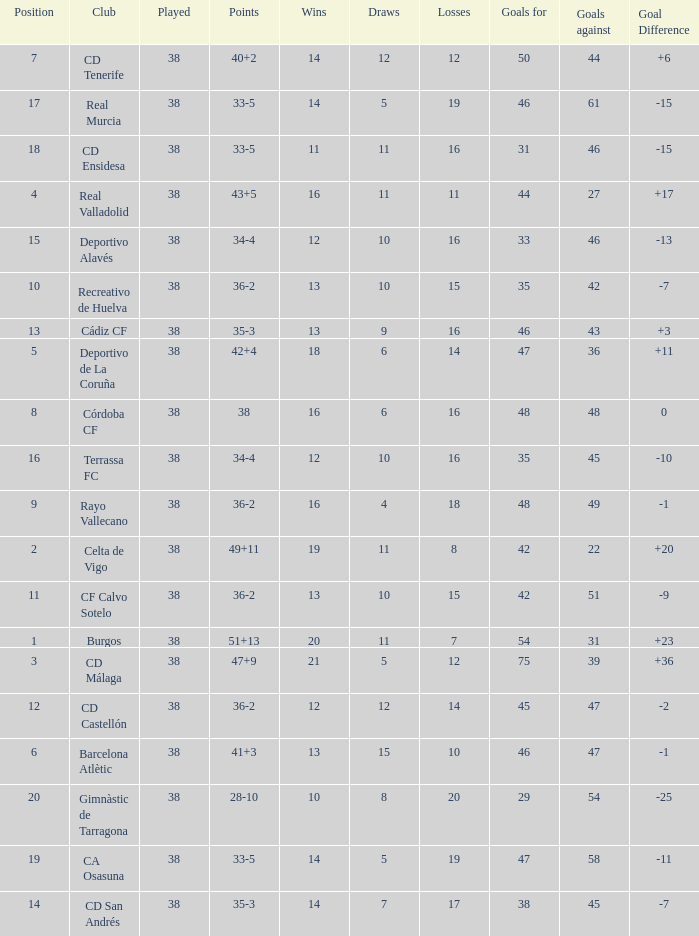Which is the lowest played with 28-10 points and goals higher than 29? None. 